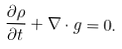<formula> <loc_0><loc_0><loc_500><loc_500>\frac { \partial \rho } { \partial { t } } + { \nabla } \cdot { g } = 0 .</formula> 